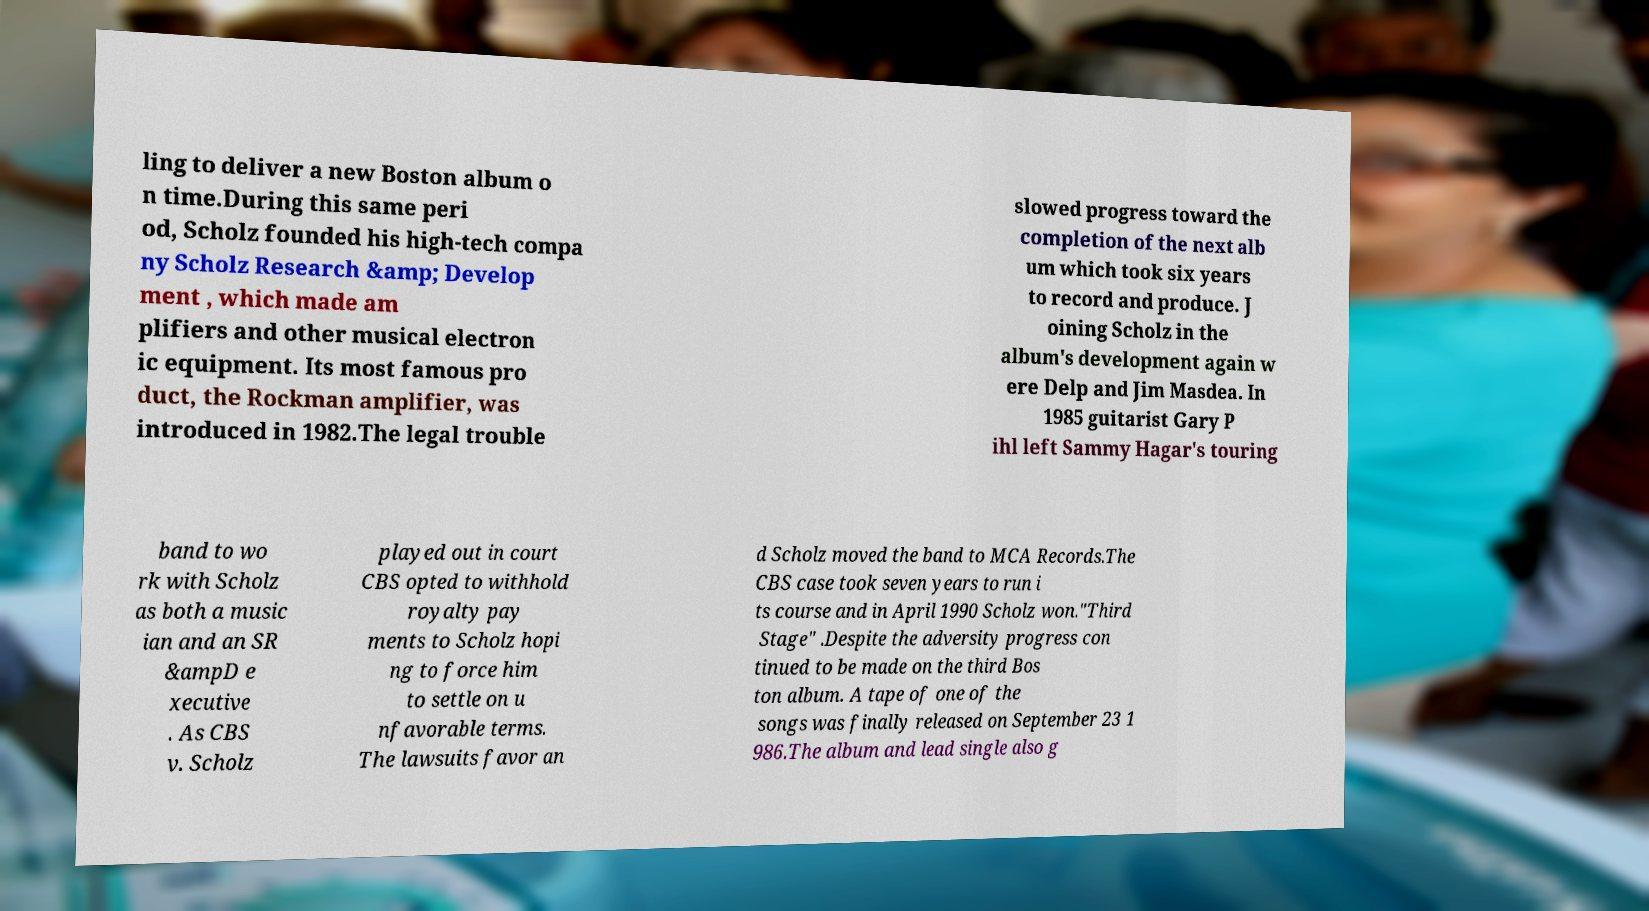What messages or text are displayed in this image? I need them in a readable, typed format. ling to deliver a new Boston album o n time.During this same peri od, Scholz founded his high-tech compa ny Scholz Research &amp; Develop ment , which made am plifiers and other musical electron ic equipment. Its most famous pro duct, the Rockman amplifier, was introduced in 1982.The legal trouble slowed progress toward the completion of the next alb um which took six years to record and produce. J oining Scholz in the album's development again w ere Delp and Jim Masdea. In 1985 guitarist Gary P ihl left Sammy Hagar's touring band to wo rk with Scholz as both a music ian and an SR &ampD e xecutive . As CBS v. Scholz played out in court CBS opted to withhold royalty pay ments to Scholz hopi ng to force him to settle on u nfavorable terms. The lawsuits favor an d Scholz moved the band to MCA Records.The CBS case took seven years to run i ts course and in April 1990 Scholz won."Third Stage" .Despite the adversity progress con tinued to be made on the third Bos ton album. A tape of one of the songs was finally released on September 23 1 986.The album and lead single also g 